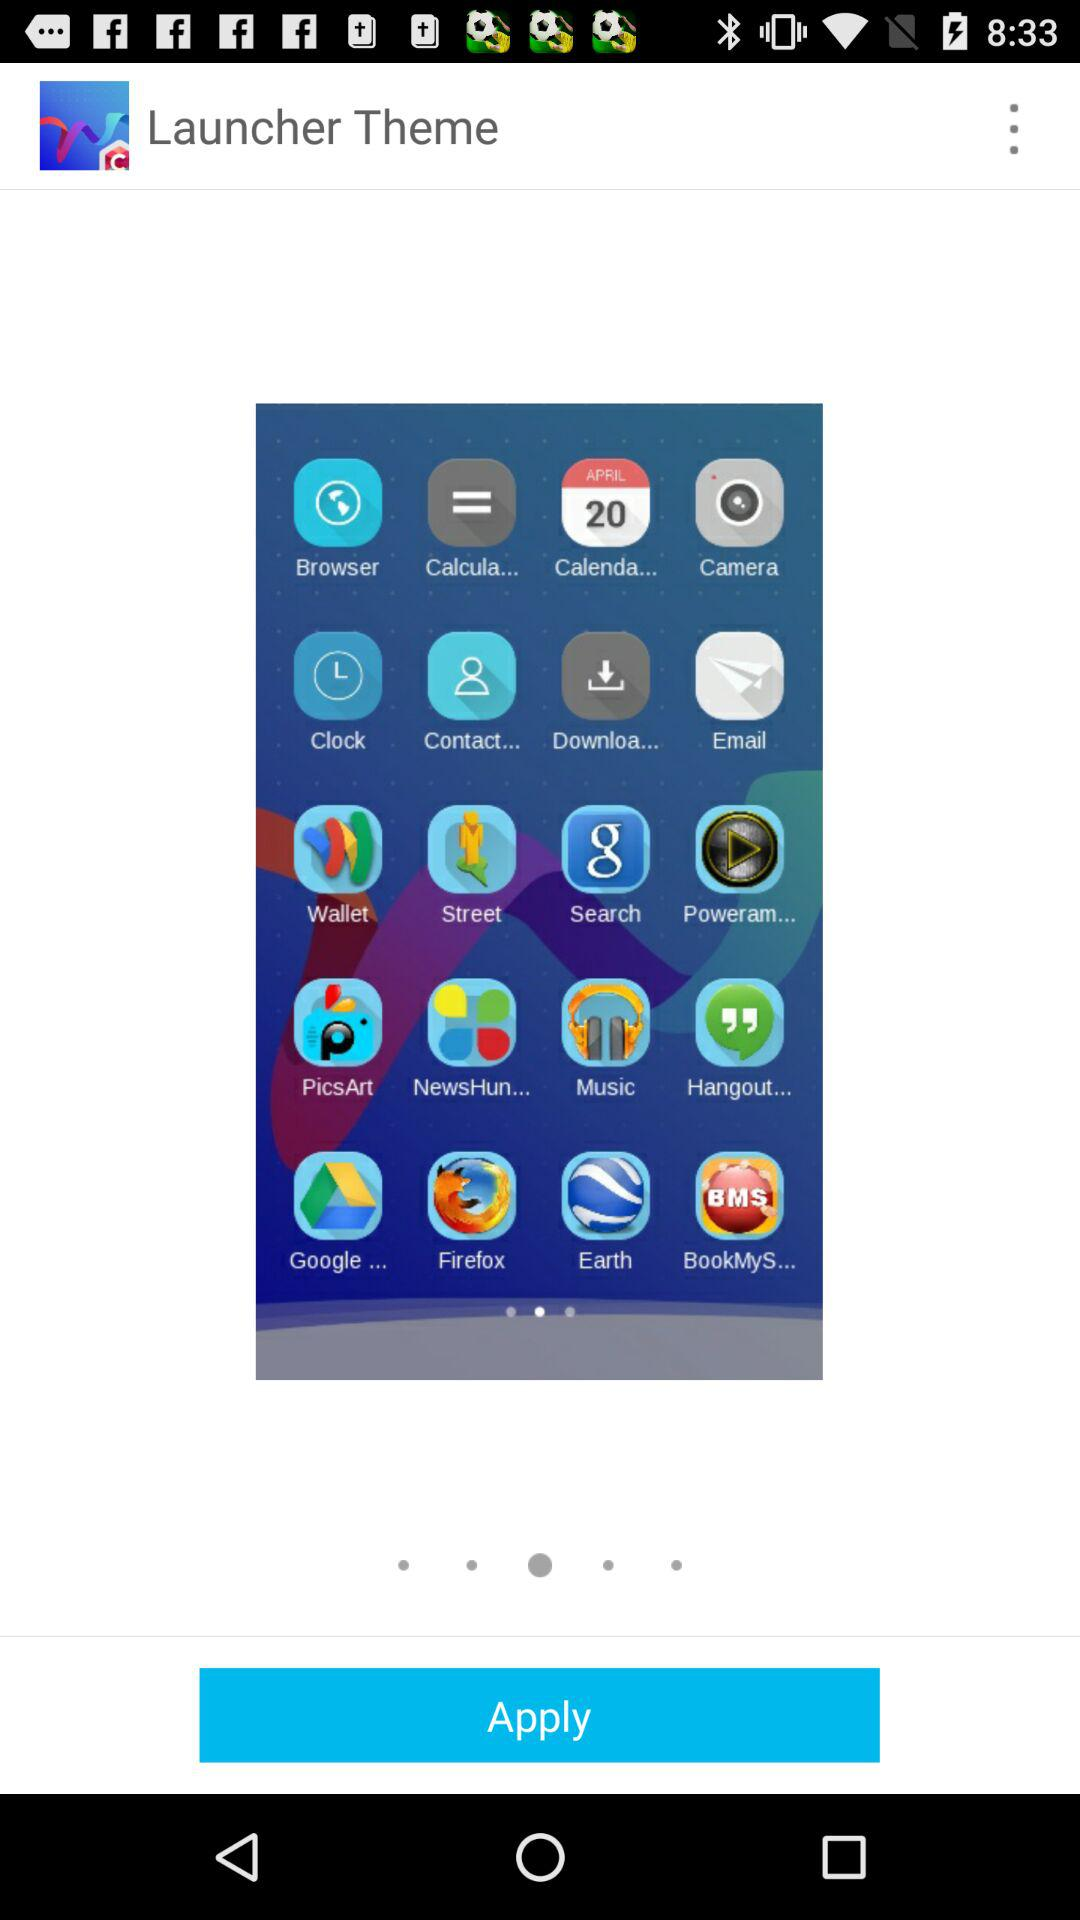What is the application name? The application name is "Launcher Theme". 